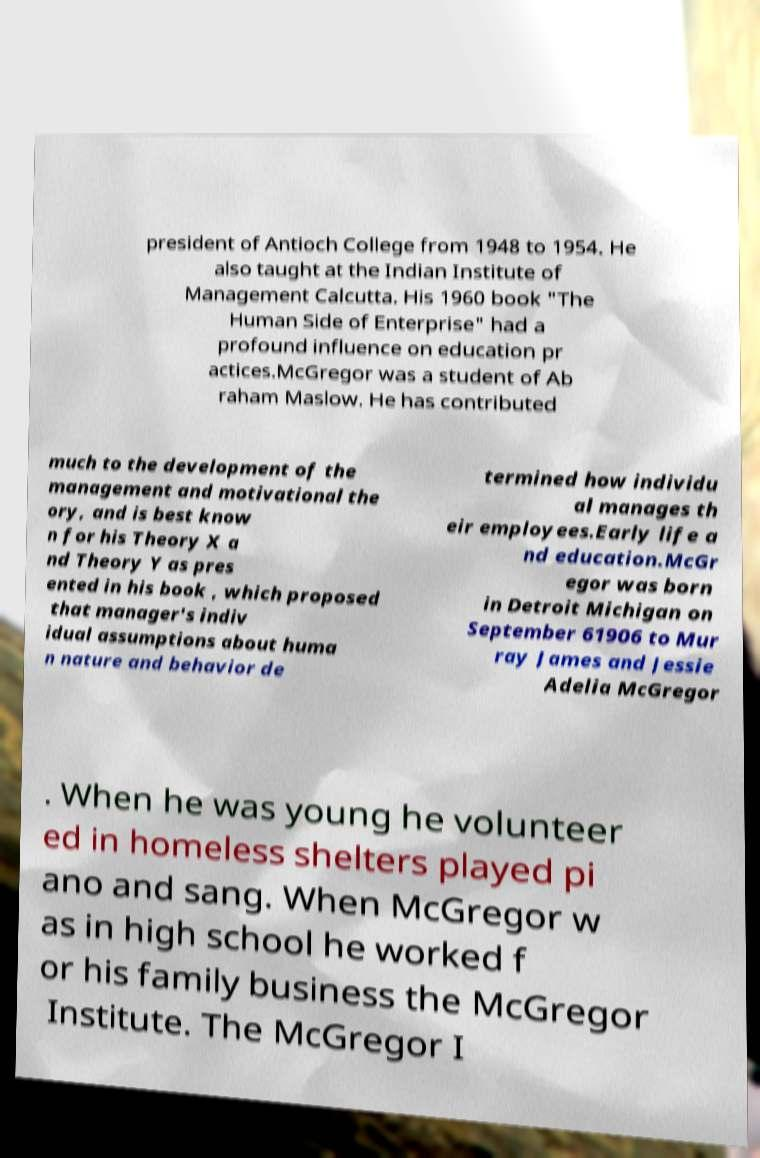Please identify and transcribe the text found in this image. president of Antioch College from 1948 to 1954. He also taught at the Indian Institute of Management Calcutta. His 1960 book "The Human Side of Enterprise" had a profound influence on education pr actices.McGregor was a student of Ab raham Maslow. He has contributed much to the development of the management and motivational the ory, and is best know n for his Theory X a nd Theory Y as pres ented in his book , which proposed that manager's indiv idual assumptions about huma n nature and behavior de termined how individu al manages th eir employees.Early life a nd education.McGr egor was born in Detroit Michigan on September 61906 to Mur ray James and Jessie Adelia McGregor . When he was young he volunteer ed in homeless shelters played pi ano and sang. When McGregor w as in high school he worked f or his family business the McGregor Institute. The McGregor I 